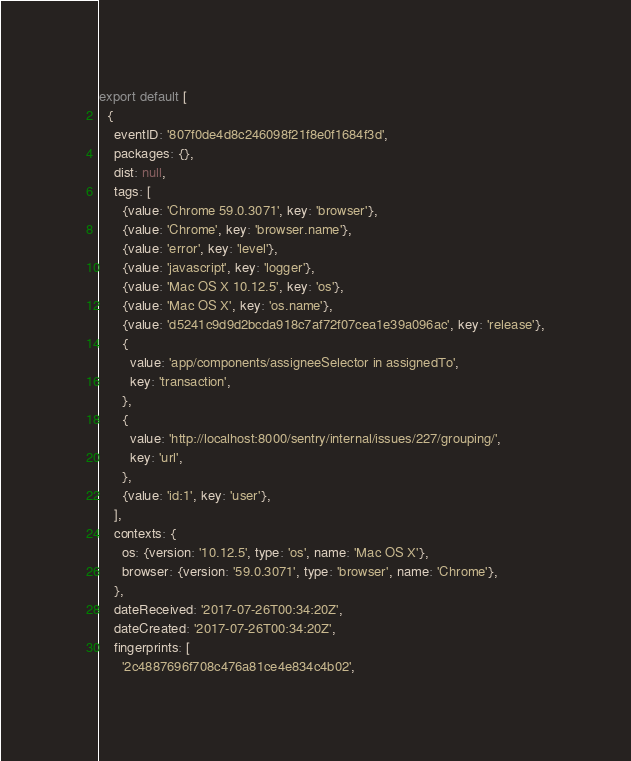Convert code to text. <code><loc_0><loc_0><loc_500><loc_500><_JavaScript_>export default [
  {
    eventID: '807f0de4d8c246098f21f8e0f1684f3d',
    packages: {},
    dist: null,
    tags: [
      {value: 'Chrome 59.0.3071', key: 'browser'},
      {value: 'Chrome', key: 'browser.name'},
      {value: 'error', key: 'level'},
      {value: 'javascript', key: 'logger'},
      {value: 'Mac OS X 10.12.5', key: 'os'},
      {value: 'Mac OS X', key: 'os.name'},
      {value: 'd5241c9d9d2bcda918c7af72f07cea1e39a096ac', key: 'release'},
      {
        value: 'app/components/assigneeSelector in assignedTo',
        key: 'transaction',
      },
      {
        value: 'http://localhost:8000/sentry/internal/issues/227/grouping/',
        key: 'url',
      },
      {value: 'id:1', key: 'user'},
    ],
    contexts: {
      os: {version: '10.12.5', type: 'os', name: 'Mac OS X'},
      browser: {version: '59.0.3071', type: 'browser', name: 'Chrome'},
    },
    dateReceived: '2017-07-26T00:34:20Z',
    dateCreated: '2017-07-26T00:34:20Z',
    fingerprints: [
      '2c4887696f708c476a81ce4e834c4b02',</code> 